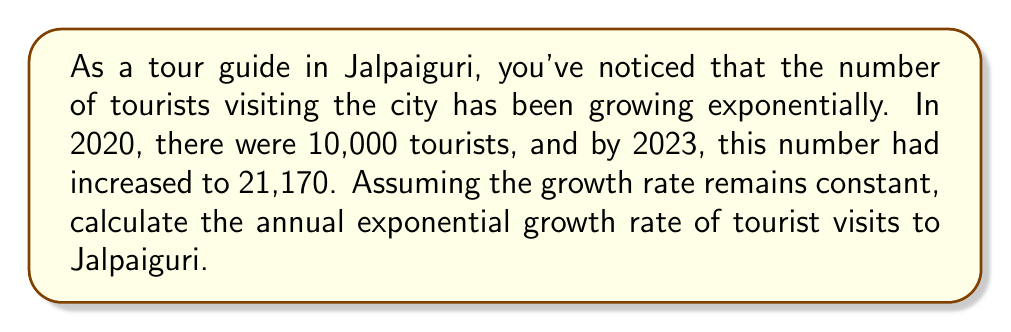Teach me how to tackle this problem. To solve this problem, we'll use the exponential growth formula:

$$A = P(1 + r)^t$$

Where:
$A$ = Final amount
$P$ = Initial amount
$r$ = Annual growth rate
$t$ = Time in years

We know:
$P = 10,000$ (tourists in 2020)
$A = 21,170$ (tourists in 2023)
$t = 3$ years (from 2020 to 2023)

Let's substitute these values into the equation:

$$21,170 = 10,000(1 + r)^3$$

Now, we need to solve for $r$:

1) Divide both sides by 10,000:
   $$2.117 = (1 + r)^3$$

2) Take the cube root of both sides:
   $$\sqrt[3]{2.117} = 1 + r$$

3) Subtract 1 from both sides:
   $$\sqrt[3]{2.117} - 1 = r$$

4) Calculate the value:
   $$r \approx 1.2859 - 1 = 0.2859$$

5) Convert to a percentage:
   $$r \approx 0.2859 \times 100\% = 28.59\%$$

Therefore, the annual exponential growth rate of tourist visits to Jalpaiguri is approximately 28.59%.
Answer: The annual exponential growth rate of tourist visits to Jalpaiguri is approximately 28.59%. 